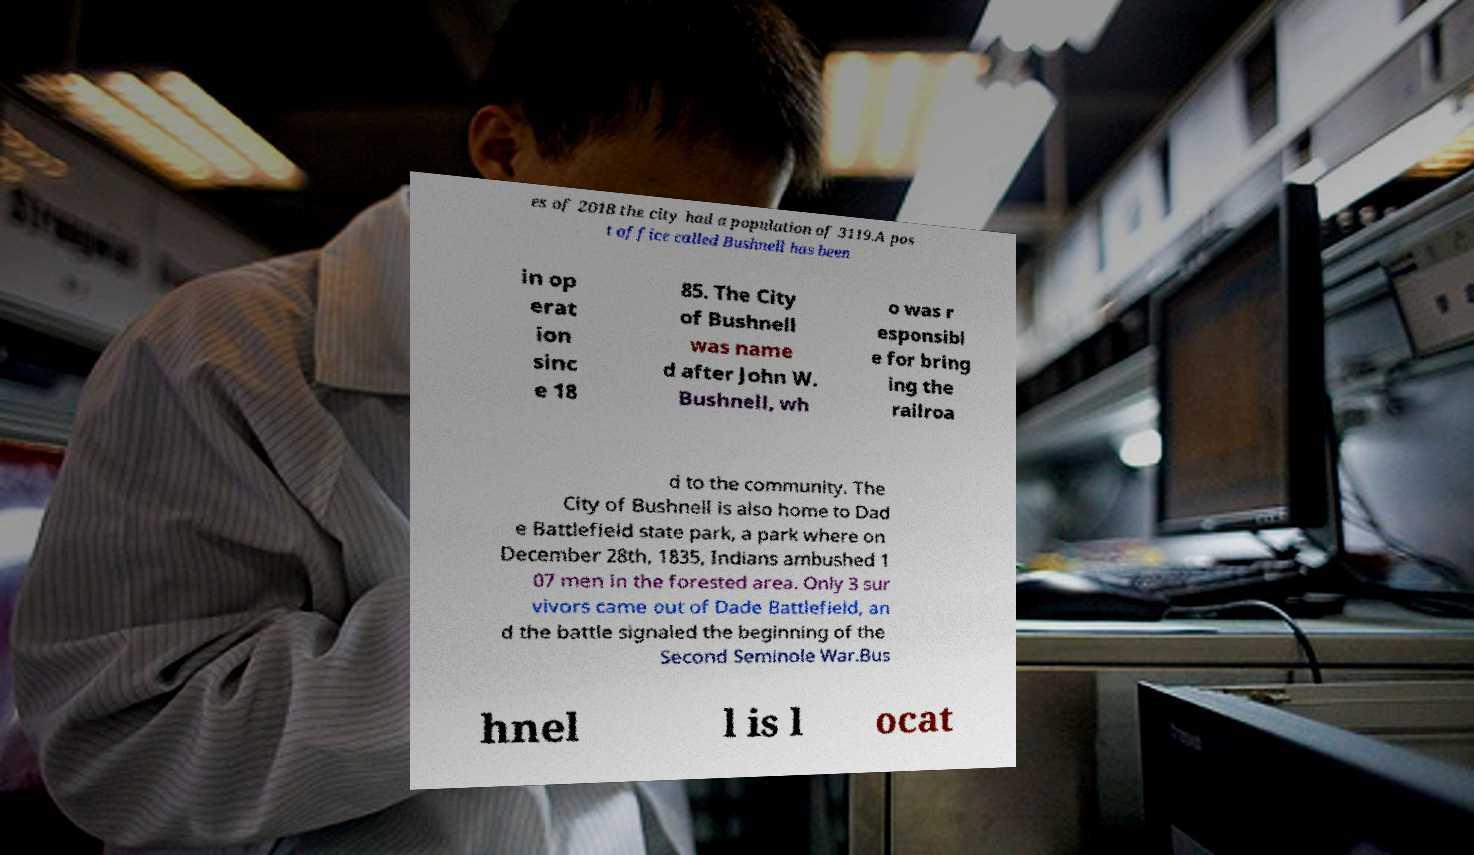Can you read and provide the text displayed in the image?This photo seems to have some interesting text. Can you extract and type it out for me? es of 2018 the city had a population of 3119.A pos t office called Bushnell has been in op erat ion sinc e 18 85. The City of Bushnell was name d after John W. Bushnell, wh o was r esponsibl e for bring ing the railroa d to the community. The City of Bushnell is also home to Dad e Battlefield state park, a park where on December 28th, 1835, Indians ambushed 1 07 men in the forested area. Only 3 sur vivors came out of Dade Battlefield, an d the battle signaled the beginning of the Second Seminole War.Bus hnel l is l ocat 